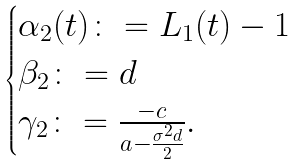<formula> <loc_0><loc_0><loc_500><loc_500>\begin{cases} \alpha _ { 2 } ( t ) \colon = L _ { 1 } ( t ) - 1 \\ \beta _ { 2 } \colon = d \\ \gamma _ { 2 } \colon = \frac { - c } { a - \frac { \sigma ^ { 2 } d } { 2 } } . \end{cases}</formula> 